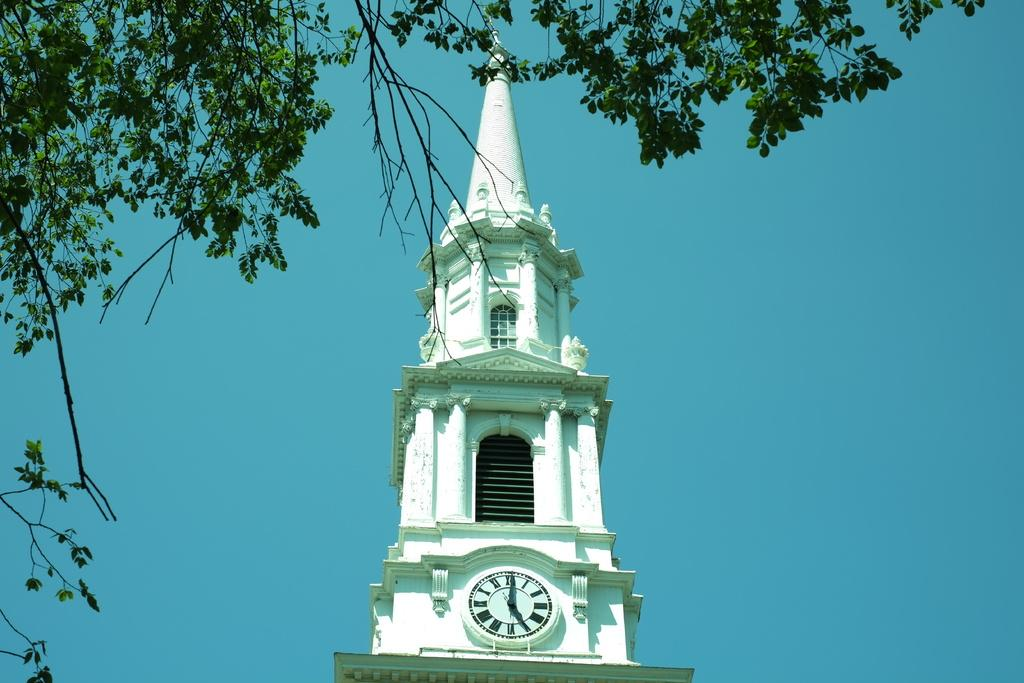What is the main structure in the image? There is a clock tower in the image. What can be seen in the background of the image? The sky is visible in the background of the image. What type of plant is present in the image? There is a tree in the image. What type of coastline can be seen in the image? There is no coastline present in the image; it features a clock tower, sky, and a tree. What advice does the father give in the image? There is no father or advice present in the image. 